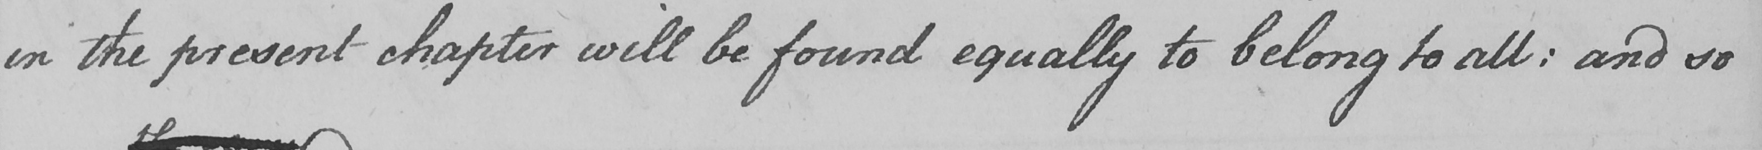What is written in this line of handwriting? in the present chapter will be found equally to belong to all :  and so 